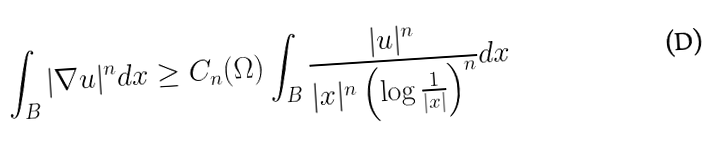<formula> <loc_0><loc_0><loc_500><loc_500>\int _ { B } | \nabla u | ^ { n } d x \geq C _ { n } ( \Omega ) \int _ { B } \frac { | u | ^ { n } } { | x | ^ { n } \left ( \log { \frac { 1 } { | x | } } \right ) ^ { n } } d x</formula> 